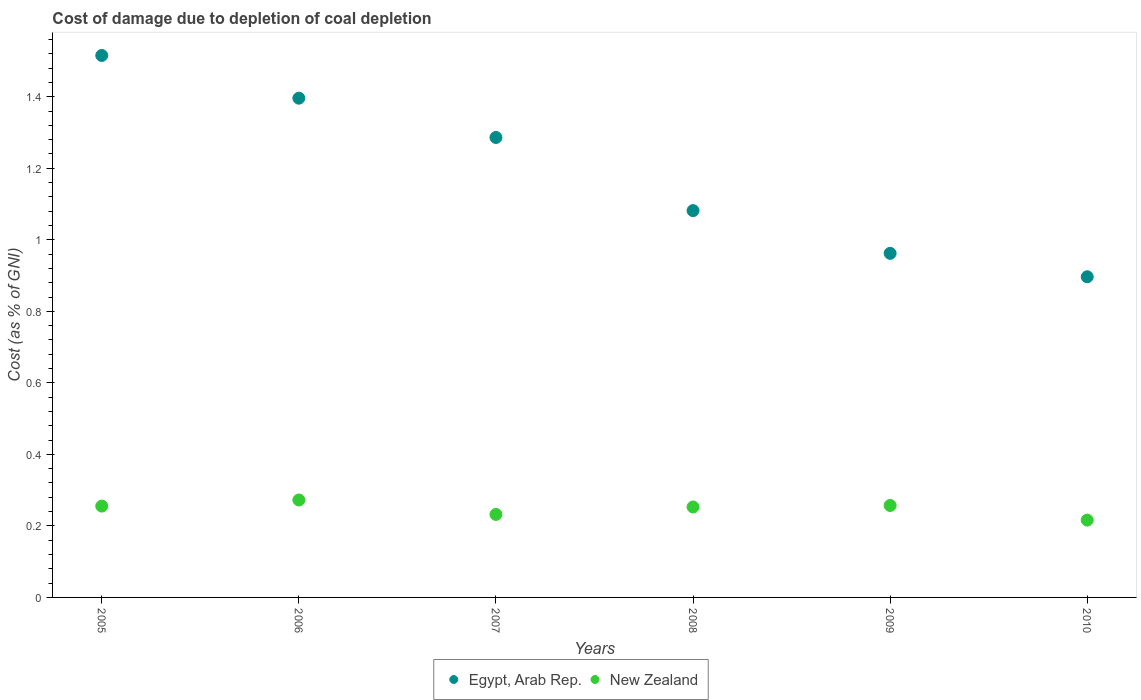Is the number of dotlines equal to the number of legend labels?
Offer a terse response. Yes. What is the cost of damage caused due to coal depletion in New Zealand in 2005?
Offer a very short reply. 0.26. Across all years, what is the maximum cost of damage caused due to coal depletion in New Zealand?
Provide a succinct answer. 0.27. Across all years, what is the minimum cost of damage caused due to coal depletion in Egypt, Arab Rep.?
Provide a short and direct response. 0.9. In which year was the cost of damage caused due to coal depletion in Egypt, Arab Rep. minimum?
Your response must be concise. 2010. What is the total cost of damage caused due to coal depletion in New Zealand in the graph?
Keep it short and to the point. 1.49. What is the difference between the cost of damage caused due to coal depletion in Egypt, Arab Rep. in 2006 and that in 2007?
Provide a succinct answer. 0.11. What is the difference between the cost of damage caused due to coal depletion in Egypt, Arab Rep. in 2009 and the cost of damage caused due to coal depletion in New Zealand in 2010?
Provide a short and direct response. 0.75. What is the average cost of damage caused due to coal depletion in New Zealand per year?
Offer a terse response. 0.25. In the year 2006, what is the difference between the cost of damage caused due to coal depletion in Egypt, Arab Rep. and cost of damage caused due to coal depletion in New Zealand?
Your answer should be very brief. 1.12. In how many years, is the cost of damage caused due to coal depletion in Egypt, Arab Rep. greater than 0.52 %?
Ensure brevity in your answer.  6. What is the ratio of the cost of damage caused due to coal depletion in Egypt, Arab Rep. in 2007 to that in 2010?
Your answer should be compact. 1.43. What is the difference between the highest and the second highest cost of damage caused due to coal depletion in Egypt, Arab Rep.?
Provide a short and direct response. 0.12. What is the difference between the highest and the lowest cost of damage caused due to coal depletion in New Zealand?
Your response must be concise. 0.06. In how many years, is the cost of damage caused due to coal depletion in New Zealand greater than the average cost of damage caused due to coal depletion in New Zealand taken over all years?
Make the answer very short. 4. Is the sum of the cost of damage caused due to coal depletion in Egypt, Arab Rep. in 2007 and 2009 greater than the maximum cost of damage caused due to coal depletion in New Zealand across all years?
Provide a succinct answer. Yes. Does the cost of damage caused due to coal depletion in New Zealand monotonically increase over the years?
Provide a succinct answer. No. Is the cost of damage caused due to coal depletion in New Zealand strictly greater than the cost of damage caused due to coal depletion in Egypt, Arab Rep. over the years?
Provide a short and direct response. No. Is the cost of damage caused due to coal depletion in Egypt, Arab Rep. strictly less than the cost of damage caused due to coal depletion in New Zealand over the years?
Make the answer very short. No. Does the graph contain grids?
Provide a short and direct response. No. Where does the legend appear in the graph?
Ensure brevity in your answer.  Bottom center. How are the legend labels stacked?
Provide a succinct answer. Horizontal. What is the title of the graph?
Ensure brevity in your answer.  Cost of damage due to depletion of coal depletion. What is the label or title of the X-axis?
Keep it short and to the point. Years. What is the label or title of the Y-axis?
Give a very brief answer. Cost (as % of GNI). What is the Cost (as % of GNI) in Egypt, Arab Rep. in 2005?
Provide a succinct answer. 1.52. What is the Cost (as % of GNI) in New Zealand in 2005?
Offer a terse response. 0.26. What is the Cost (as % of GNI) in Egypt, Arab Rep. in 2006?
Give a very brief answer. 1.4. What is the Cost (as % of GNI) of New Zealand in 2006?
Offer a terse response. 0.27. What is the Cost (as % of GNI) of Egypt, Arab Rep. in 2007?
Keep it short and to the point. 1.29. What is the Cost (as % of GNI) of New Zealand in 2007?
Offer a very short reply. 0.23. What is the Cost (as % of GNI) in Egypt, Arab Rep. in 2008?
Give a very brief answer. 1.08. What is the Cost (as % of GNI) in New Zealand in 2008?
Keep it short and to the point. 0.25. What is the Cost (as % of GNI) in Egypt, Arab Rep. in 2009?
Your answer should be compact. 0.96. What is the Cost (as % of GNI) of New Zealand in 2009?
Your answer should be very brief. 0.26. What is the Cost (as % of GNI) of Egypt, Arab Rep. in 2010?
Your response must be concise. 0.9. What is the Cost (as % of GNI) in New Zealand in 2010?
Your response must be concise. 0.22. Across all years, what is the maximum Cost (as % of GNI) of Egypt, Arab Rep.?
Your answer should be very brief. 1.52. Across all years, what is the maximum Cost (as % of GNI) of New Zealand?
Give a very brief answer. 0.27. Across all years, what is the minimum Cost (as % of GNI) of Egypt, Arab Rep.?
Provide a succinct answer. 0.9. Across all years, what is the minimum Cost (as % of GNI) in New Zealand?
Ensure brevity in your answer.  0.22. What is the total Cost (as % of GNI) in Egypt, Arab Rep. in the graph?
Your answer should be compact. 7.14. What is the total Cost (as % of GNI) of New Zealand in the graph?
Ensure brevity in your answer.  1.49. What is the difference between the Cost (as % of GNI) of Egypt, Arab Rep. in 2005 and that in 2006?
Give a very brief answer. 0.12. What is the difference between the Cost (as % of GNI) of New Zealand in 2005 and that in 2006?
Your answer should be compact. -0.02. What is the difference between the Cost (as % of GNI) in Egypt, Arab Rep. in 2005 and that in 2007?
Your answer should be very brief. 0.23. What is the difference between the Cost (as % of GNI) in New Zealand in 2005 and that in 2007?
Your response must be concise. 0.02. What is the difference between the Cost (as % of GNI) of Egypt, Arab Rep. in 2005 and that in 2008?
Provide a succinct answer. 0.43. What is the difference between the Cost (as % of GNI) of New Zealand in 2005 and that in 2008?
Make the answer very short. 0. What is the difference between the Cost (as % of GNI) in Egypt, Arab Rep. in 2005 and that in 2009?
Offer a very short reply. 0.55. What is the difference between the Cost (as % of GNI) of New Zealand in 2005 and that in 2009?
Your answer should be very brief. -0. What is the difference between the Cost (as % of GNI) of Egypt, Arab Rep. in 2005 and that in 2010?
Your answer should be very brief. 0.62. What is the difference between the Cost (as % of GNI) of New Zealand in 2005 and that in 2010?
Your response must be concise. 0.04. What is the difference between the Cost (as % of GNI) in Egypt, Arab Rep. in 2006 and that in 2007?
Provide a succinct answer. 0.11. What is the difference between the Cost (as % of GNI) in New Zealand in 2006 and that in 2007?
Offer a terse response. 0.04. What is the difference between the Cost (as % of GNI) of Egypt, Arab Rep. in 2006 and that in 2008?
Offer a very short reply. 0.31. What is the difference between the Cost (as % of GNI) in New Zealand in 2006 and that in 2008?
Offer a terse response. 0.02. What is the difference between the Cost (as % of GNI) in Egypt, Arab Rep. in 2006 and that in 2009?
Keep it short and to the point. 0.43. What is the difference between the Cost (as % of GNI) in New Zealand in 2006 and that in 2009?
Ensure brevity in your answer.  0.02. What is the difference between the Cost (as % of GNI) in Egypt, Arab Rep. in 2006 and that in 2010?
Keep it short and to the point. 0.5. What is the difference between the Cost (as % of GNI) in New Zealand in 2006 and that in 2010?
Give a very brief answer. 0.06. What is the difference between the Cost (as % of GNI) in Egypt, Arab Rep. in 2007 and that in 2008?
Give a very brief answer. 0.2. What is the difference between the Cost (as % of GNI) of New Zealand in 2007 and that in 2008?
Provide a succinct answer. -0.02. What is the difference between the Cost (as % of GNI) of Egypt, Arab Rep. in 2007 and that in 2009?
Give a very brief answer. 0.32. What is the difference between the Cost (as % of GNI) in New Zealand in 2007 and that in 2009?
Your answer should be compact. -0.03. What is the difference between the Cost (as % of GNI) in Egypt, Arab Rep. in 2007 and that in 2010?
Keep it short and to the point. 0.39. What is the difference between the Cost (as % of GNI) of New Zealand in 2007 and that in 2010?
Ensure brevity in your answer.  0.02. What is the difference between the Cost (as % of GNI) of Egypt, Arab Rep. in 2008 and that in 2009?
Keep it short and to the point. 0.12. What is the difference between the Cost (as % of GNI) of New Zealand in 2008 and that in 2009?
Make the answer very short. -0. What is the difference between the Cost (as % of GNI) in Egypt, Arab Rep. in 2008 and that in 2010?
Offer a very short reply. 0.18. What is the difference between the Cost (as % of GNI) of New Zealand in 2008 and that in 2010?
Make the answer very short. 0.04. What is the difference between the Cost (as % of GNI) of Egypt, Arab Rep. in 2009 and that in 2010?
Your response must be concise. 0.07. What is the difference between the Cost (as % of GNI) in New Zealand in 2009 and that in 2010?
Offer a terse response. 0.04. What is the difference between the Cost (as % of GNI) of Egypt, Arab Rep. in 2005 and the Cost (as % of GNI) of New Zealand in 2006?
Your answer should be very brief. 1.24. What is the difference between the Cost (as % of GNI) of Egypt, Arab Rep. in 2005 and the Cost (as % of GNI) of New Zealand in 2007?
Ensure brevity in your answer.  1.28. What is the difference between the Cost (as % of GNI) of Egypt, Arab Rep. in 2005 and the Cost (as % of GNI) of New Zealand in 2008?
Ensure brevity in your answer.  1.26. What is the difference between the Cost (as % of GNI) of Egypt, Arab Rep. in 2005 and the Cost (as % of GNI) of New Zealand in 2009?
Keep it short and to the point. 1.26. What is the difference between the Cost (as % of GNI) in Egypt, Arab Rep. in 2005 and the Cost (as % of GNI) in New Zealand in 2010?
Your answer should be very brief. 1.3. What is the difference between the Cost (as % of GNI) in Egypt, Arab Rep. in 2006 and the Cost (as % of GNI) in New Zealand in 2007?
Provide a succinct answer. 1.16. What is the difference between the Cost (as % of GNI) in Egypt, Arab Rep. in 2006 and the Cost (as % of GNI) in New Zealand in 2008?
Keep it short and to the point. 1.14. What is the difference between the Cost (as % of GNI) in Egypt, Arab Rep. in 2006 and the Cost (as % of GNI) in New Zealand in 2009?
Provide a succinct answer. 1.14. What is the difference between the Cost (as % of GNI) in Egypt, Arab Rep. in 2006 and the Cost (as % of GNI) in New Zealand in 2010?
Make the answer very short. 1.18. What is the difference between the Cost (as % of GNI) of Egypt, Arab Rep. in 2007 and the Cost (as % of GNI) of New Zealand in 2009?
Offer a very short reply. 1.03. What is the difference between the Cost (as % of GNI) of Egypt, Arab Rep. in 2007 and the Cost (as % of GNI) of New Zealand in 2010?
Ensure brevity in your answer.  1.07. What is the difference between the Cost (as % of GNI) in Egypt, Arab Rep. in 2008 and the Cost (as % of GNI) in New Zealand in 2009?
Make the answer very short. 0.82. What is the difference between the Cost (as % of GNI) of Egypt, Arab Rep. in 2008 and the Cost (as % of GNI) of New Zealand in 2010?
Your answer should be compact. 0.87. What is the difference between the Cost (as % of GNI) in Egypt, Arab Rep. in 2009 and the Cost (as % of GNI) in New Zealand in 2010?
Give a very brief answer. 0.75. What is the average Cost (as % of GNI) of Egypt, Arab Rep. per year?
Make the answer very short. 1.19. What is the average Cost (as % of GNI) in New Zealand per year?
Ensure brevity in your answer.  0.25. In the year 2005, what is the difference between the Cost (as % of GNI) of Egypt, Arab Rep. and Cost (as % of GNI) of New Zealand?
Your response must be concise. 1.26. In the year 2006, what is the difference between the Cost (as % of GNI) of Egypt, Arab Rep. and Cost (as % of GNI) of New Zealand?
Give a very brief answer. 1.12. In the year 2007, what is the difference between the Cost (as % of GNI) of Egypt, Arab Rep. and Cost (as % of GNI) of New Zealand?
Give a very brief answer. 1.05. In the year 2008, what is the difference between the Cost (as % of GNI) of Egypt, Arab Rep. and Cost (as % of GNI) of New Zealand?
Make the answer very short. 0.83. In the year 2009, what is the difference between the Cost (as % of GNI) in Egypt, Arab Rep. and Cost (as % of GNI) in New Zealand?
Your answer should be compact. 0.71. In the year 2010, what is the difference between the Cost (as % of GNI) in Egypt, Arab Rep. and Cost (as % of GNI) in New Zealand?
Make the answer very short. 0.68. What is the ratio of the Cost (as % of GNI) of Egypt, Arab Rep. in 2005 to that in 2006?
Provide a succinct answer. 1.09. What is the ratio of the Cost (as % of GNI) in New Zealand in 2005 to that in 2006?
Ensure brevity in your answer.  0.94. What is the ratio of the Cost (as % of GNI) of Egypt, Arab Rep. in 2005 to that in 2007?
Your answer should be compact. 1.18. What is the ratio of the Cost (as % of GNI) of New Zealand in 2005 to that in 2007?
Give a very brief answer. 1.1. What is the ratio of the Cost (as % of GNI) in Egypt, Arab Rep. in 2005 to that in 2008?
Provide a short and direct response. 1.4. What is the ratio of the Cost (as % of GNI) of New Zealand in 2005 to that in 2008?
Keep it short and to the point. 1.01. What is the ratio of the Cost (as % of GNI) of Egypt, Arab Rep. in 2005 to that in 2009?
Offer a terse response. 1.57. What is the ratio of the Cost (as % of GNI) of Egypt, Arab Rep. in 2005 to that in 2010?
Your answer should be compact. 1.69. What is the ratio of the Cost (as % of GNI) in New Zealand in 2005 to that in 2010?
Your answer should be very brief. 1.18. What is the ratio of the Cost (as % of GNI) in Egypt, Arab Rep. in 2006 to that in 2007?
Offer a very short reply. 1.09. What is the ratio of the Cost (as % of GNI) in New Zealand in 2006 to that in 2007?
Give a very brief answer. 1.17. What is the ratio of the Cost (as % of GNI) of Egypt, Arab Rep. in 2006 to that in 2008?
Offer a very short reply. 1.29. What is the ratio of the Cost (as % of GNI) in New Zealand in 2006 to that in 2008?
Offer a very short reply. 1.08. What is the ratio of the Cost (as % of GNI) in Egypt, Arab Rep. in 2006 to that in 2009?
Provide a succinct answer. 1.45. What is the ratio of the Cost (as % of GNI) of New Zealand in 2006 to that in 2009?
Your response must be concise. 1.06. What is the ratio of the Cost (as % of GNI) in Egypt, Arab Rep. in 2006 to that in 2010?
Offer a very short reply. 1.56. What is the ratio of the Cost (as % of GNI) in New Zealand in 2006 to that in 2010?
Provide a succinct answer. 1.26. What is the ratio of the Cost (as % of GNI) in Egypt, Arab Rep. in 2007 to that in 2008?
Your answer should be very brief. 1.19. What is the ratio of the Cost (as % of GNI) in New Zealand in 2007 to that in 2008?
Ensure brevity in your answer.  0.92. What is the ratio of the Cost (as % of GNI) of Egypt, Arab Rep. in 2007 to that in 2009?
Keep it short and to the point. 1.34. What is the ratio of the Cost (as % of GNI) of New Zealand in 2007 to that in 2009?
Ensure brevity in your answer.  0.9. What is the ratio of the Cost (as % of GNI) in Egypt, Arab Rep. in 2007 to that in 2010?
Your answer should be very brief. 1.43. What is the ratio of the Cost (as % of GNI) in New Zealand in 2007 to that in 2010?
Provide a succinct answer. 1.07. What is the ratio of the Cost (as % of GNI) of Egypt, Arab Rep. in 2008 to that in 2009?
Offer a very short reply. 1.12. What is the ratio of the Cost (as % of GNI) in New Zealand in 2008 to that in 2009?
Give a very brief answer. 0.98. What is the ratio of the Cost (as % of GNI) of Egypt, Arab Rep. in 2008 to that in 2010?
Your answer should be compact. 1.21. What is the ratio of the Cost (as % of GNI) in New Zealand in 2008 to that in 2010?
Your response must be concise. 1.17. What is the ratio of the Cost (as % of GNI) in Egypt, Arab Rep. in 2009 to that in 2010?
Offer a very short reply. 1.07. What is the ratio of the Cost (as % of GNI) of New Zealand in 2009 to that in 2010?
Give a very brief answer. 1.19. What is the difference between the highest and the second highest Cost (as % of GNI) of Egypt, Arab Rep.?
Your answer should be very brief. 0.12. What is the difference between the highest and the second highest Cost (as % of GNI) in New Zealand?
Give a very brief answer. 0.02. What is the difference between the highest and the lowest Cost (as % of GNI) of Egypt, Arab Rep.?
Your response must be concise. 0.62. What is the difference between the highest and the lowest Cost (as % of GNI) of New Zealand?
Your response must be concise. 0.06. 